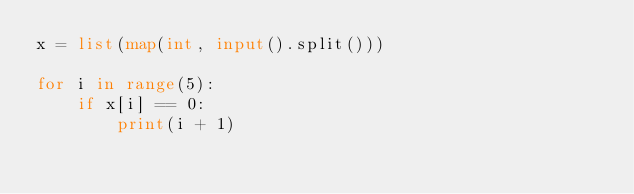Convert code to text. <code><loc_0><loc_0><loc_500><loc_500><_Python_>x = list(map(int, input().split()))

for i in range(5):
    if x[i] == 0:
        print(i + 1)
</code> 